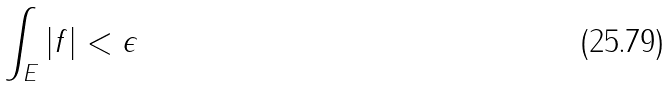<formula> <loc_0><loc_0><loc_500><loc_500>\int _ { E } | f | < \epsilon</formula> 